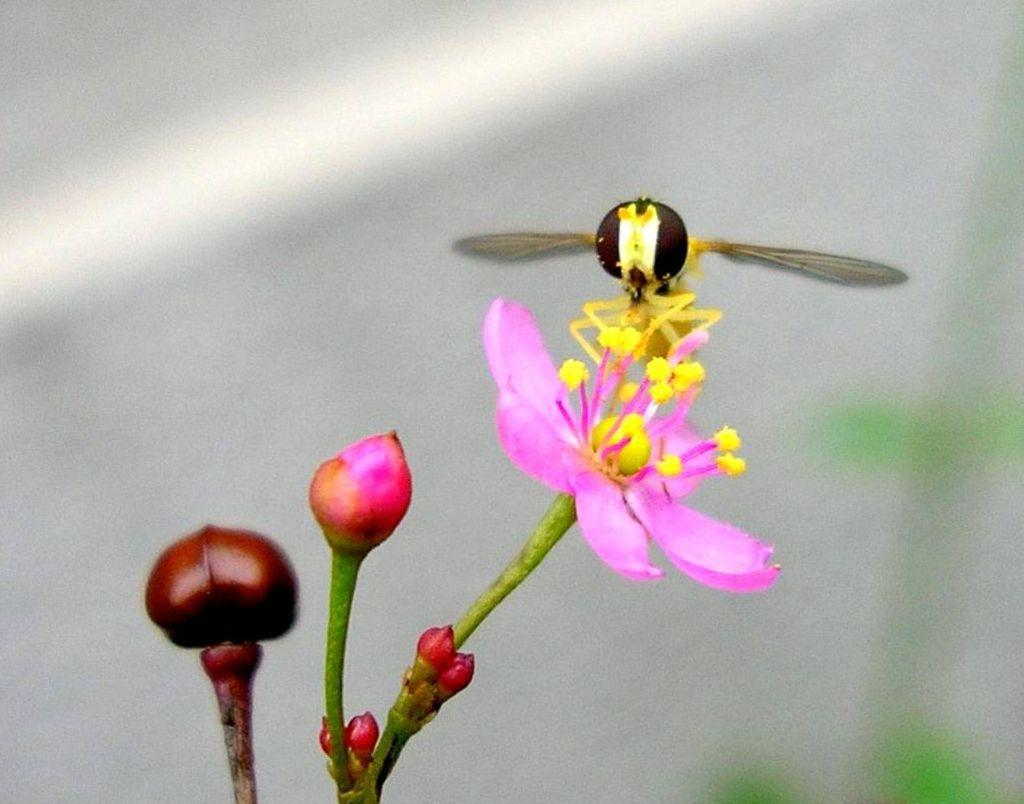What is the main subject of the image? There is a honey bee on a flower in the image. What is the state of the flowers in the image? There are flower buds in the image. Can you describe the background of the image? There is a blurred image in the background of the picture. What type of pet can be seen playing in the field in the image? There is no pet or field present in the image; it features a honey bee on a flower with flower buds and a blurred background. 